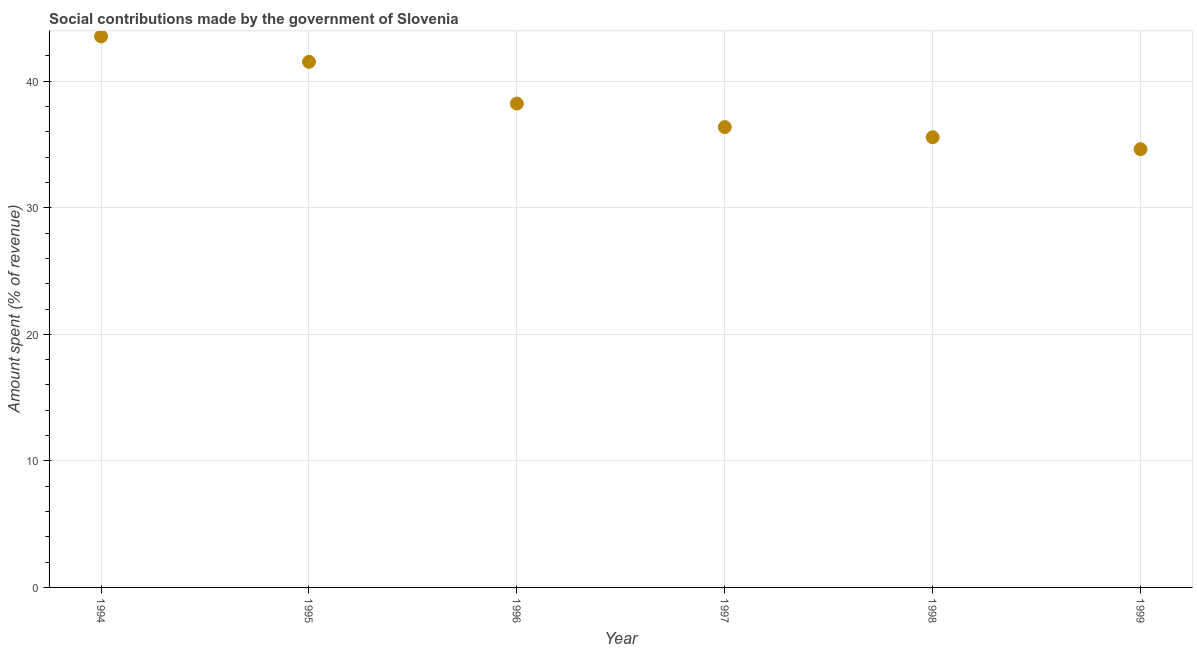What is the amount spent in making social contributions in 1994?
Your response must be concise. 43.54. Across all years, what is the maximum amount spent in making social contributions?
Offer a very short reply. 43.54. Across all years, what is the minimum amount spent in making social contributions?
Your response must be concise. 34.63. In which year was the amount spent in making social contributions maximum?
Keep it short and to the point. 1994. In which year was the amount spent in making social contributions minimum?
Ensure brevity in your answer.  1999. What is the sum of the amount spent in making social contributions?
Your answer should be very brief. 229.91. What is the difference between the amount spent in making social contributions in 1994 and 1995?
Your answer should be compact. 2. What is the average amount spent in making social contributions per year?
Ensure brevity in your answer.  38.32. What is the median amount spent in making social contributions?
Keep it short and to the point. 37.31. Do a majority of the years between 1997 and 1998 (inclusive) have amount spent in making social contributions greater than 22 %?
Give a very brief answer. Yes. What is the ratio of the amount spent in making social contributions in 1994 to that in 1996?
Offer a very short reply. 1.14. Is the amount spent in making social contributions in 1994 less than that in 1995?
Your answer should be very brief. No. What is the difference between the highest and the second highest amount spent in making social contributions?
Keep it short and to the point. 2. Is the sum of the amount spent in making social contributions in 1994 and 1998 greater than the maximum amount spent in making social contributions across all years?
Provide a short and direct response. Yes. What is the difference between the highest and the lowest amount spent in making social contributions?
Your answer should be very brief. 8.91. Does the amount spent in making social contributions monotonically increase over the years?
Make the answer very short. No. Are the values on the major ticks of Y-axis written in scientific E-notation?
Provide a short and direct response. No. What is the title of the graph?
Provide a short and direct response. Social contributions made by the government of Slovenia. What is the label or title of the X-axis?
Keep it short and to the point. Year. What is the label or title of the Y-axis?
Give a very brief answer. Amount spent (% of revenue). What is the Amount spent (% of revenue) in 1994?
Keep it short and to the point. 43.54. What is the Amount spent (% of revenue) in 1995?
Keep it short and to the point. 41.54. What is the Amount spent (% of revenue) in 1996?
Give a very brief answer. 38.24. What is the Amount spent (% of revenue) in 1997?
Offer a very short reply. 36.38. What is the Amount spent (% of revenue) in 1998?
Keep it short and to the point. 35.58. What is the Amount spent (% of revenue) in 1999?
Ensure brevity in your answer.  34.63. What is the difference between the Amount spent (% of revenue) in 1994 and 1995?
Keep it short and to the point. 2. What is the difference between the Amount spent (% of revenue) in 1994 and 1996?
Offer a very short reply. 5.3. What is the difference between the Amount spent (% of revenue) in 1994 and 1997?
Offer a terse response. 7.16. What is the difference between the Amount spent (% of revenue) in 1994 and 1998?
Your response must be concise. 7.96. What is the difference between the Amount spent (% of revenue) in 1994 and 1999?
Give a very brief answer. 8.91. What is the difference between the Amount spent (% of revenue) in 1995 and 1996?
Offer a terse response. 3.3. What is the difference between the Amount spent (% of revenue) in 1995 and 1997?
Give a very brief answer. 5.16. What is the difference between the Amount spent (% of revenue) in 1995 and 1998?
Ensure brevity in your answer.  5.96. What is the difference between the Amount spent (% of revenue) in 1995 and 1999?
Your answer should be compact. 6.9. What is the difference between the Amount spent (% of revenue) in 1996 and 1997?
Offer a terse response. 1.86. What is the difference between the Amount spent (% of revenue) in 1996 and 1998?
Provide a succinct answer. 2.66. What is the difference between the Amount spent (% of revenue) in 1996 and 1999?
Your response must be concise. 3.61. What is the difference between the Amount spent (% of revenue) in 1997 and 1998?
Give a very brief answer. 0.8. What is the difference between the Amount spent (% of revenue) in 1997 and 1999?
Provide a succinct answer. 1.75. What is the difference between the Amount spent (% of revenue) in 1998 and 1999?
Your answer should be very brief. 0.94. What is the ratio of the Amount spent (% of revenue) in 1994 to that in 1995?
Your answer should be compact. 1.05. What is the ratio of the Amount spent (% of revenue) in 1994 to that in 1996?
Your response must be concise. 1.14. What is the ratio of the Amount spent (% of revenue) in 1994 to that in 1997?
Your answer should be very brief. 1.2. What is the ratio of the Amount spent (% of revenue) in 1994 to that in 1998?
Give a very brief answer. 1.22. What is the ratio of the Amount spent (% of revenue) in 1994 to that in 1999?
Your answer should be very brief. 1.26. What is the ratio of the Amount spent (% of revenue) in 1995 to that in 1996?
Give a very brief answer. 1.09. What is the ratio of the Amount spent (% of revenue) in 1995 to that in 1997?
Your response must be concise. 1.14. What is the ratio of the Amount spent (% of revenue) in 1995 to that in 1998?
Make the answer very short. 1.17. What is the ratio of the Amount spent (% of revenue) in 1995 to that in 1999?
Provide a succinct answer. 1.2. What is the ratio of the Amount spent (% of revenue) in 1996 to that in 1997?
Provide a short and direct response. 1.05. What is the ratio of the Amount spent (% of revenue) in 1996 to that in 1998?
Offer a very short reply. 1.07. What is the ratio of the Amount spent (% of revenue) in 1996 to that in 1999?
Ensure brevity in your answer.  1.1. What is the ratio of the Amount spent (% of revenue) in 1997 to that in 1998?
Your answer should be very brief. 1.02. What is the ratio of the Amount spent (% of revenue) in 1997 to that in 1999?
Your answer should be compact. 1.05. 